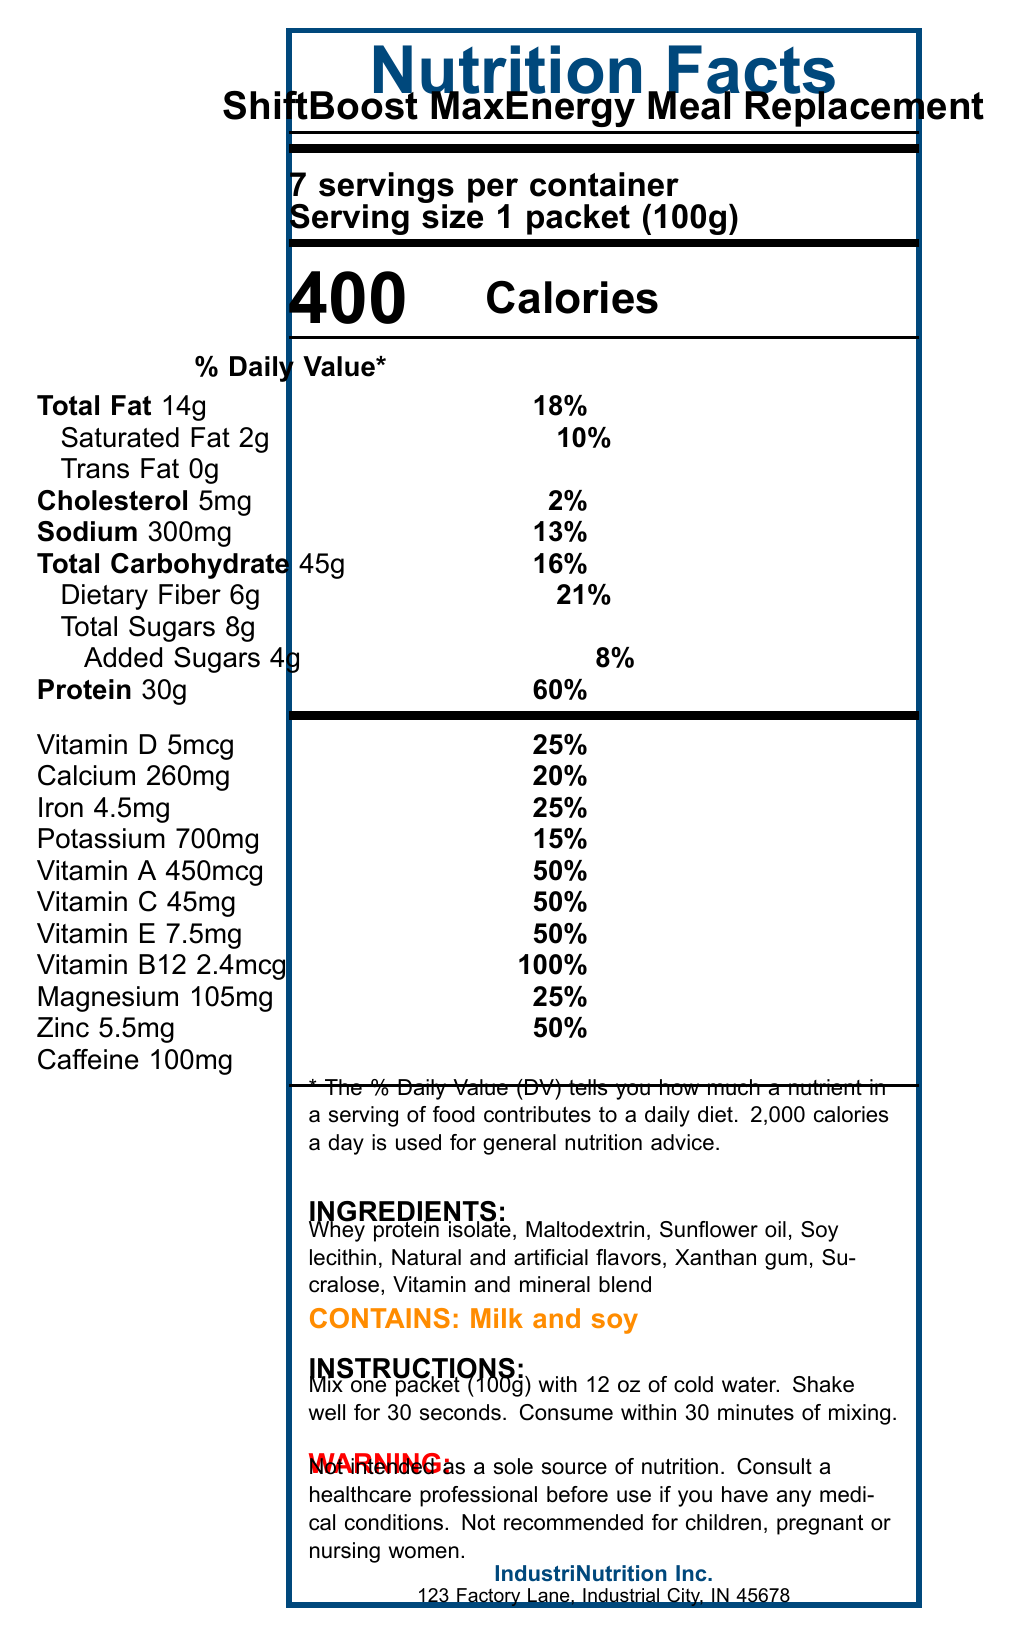what is the serving size of ShiftBoost MaxEnergy Meal Replacement? The document specifies the serving size as "1 packet (100g)".
Answer: 1 packet (100g) how many servings are there per container? The document states that there are "7 servings per container".
Answer: 7 how many grams of total fat are in one serving? The "Total Fat" section specifies the amount as "14g".
Answer: 14g what is the percentage of daily value for dietary fiber per serving? The document lists the daily value for dietary fiber as "21%".
Answer: 21% what amount of vitamin C is included per serving? The document shows the vitamin C content as "45mg".
Answer: 45mg what is the total amount of added sugars per serving? The "Added Sugars" section specifies the amount as "4g".
Answer: 4g how much protein does one serving contain? A. 14g B. 30g C. 45g D. 60g The document lists the protein content per serving as "30g".
Answer: B. 30g what is the total carbohydrate content per serving? A. 13g B. 45g C. 21g D. 30g The "Total Carbohydrate" section specifies the amount as "45g".
Answer: B. 45g does the ShiftBoost MaxEnergy Meal Replacement contain caffeine? The document includes "Caffeine 100mg" under the nutrient information.
Answer: Yes is this product recommended for children, pregnant, or nursing women? The safety warnings clearly state that it is "Not recommended for children, pregnant or nursing women".
Answer: No what are the main ingredients of ShiftBoost MaxEnergy Meal Replacement? The document lists these ingredients under the "INGREDIENTS" section.
Answer: Whey protein isolate, Maltodextrin, Sunflower oil, Soy lecithin, Natural and artificial flavors, Xanthan gum, Sucralose, Vitamin and mineral blend summarize the main information provided in the Nutrition Facts Label. The document provides comprehensive nutritional data, serving details, ingredient list, allergens, preparation instructions, safety warnings, and contact information for ShiftBoost MaxEnergy Meal Replacement.
Answer: The ShiftBoost MaxEnergy Meal Replacement provides detailed nutritional information per serving, which includes 400 calories, 14g of total fat, 30g of protein, and various vitamins and minerals. It highlights percentage daily values, ingredients, allergens, preparation, and safety instructions, as well as manufacturer details. what certifications does IndustriNutrition Inc. have? The certifications are not shown in the document. The answer cannot be determined based on the visual information provided.
Answer: Cannot be determined what is the sodium content per serving? The document specifies the sodium content as "300mg".
Answer: 300mg how much calcium does one serving contain? The document lists the calcium content as "260mg".
Answer: 260mg what is the serving size of this meal replacement? The document specifies the serving size as "1 packet (100g)".
Answer: 1 packet (100g) how many milligrams of magnesium are in one serving? The magnesium content per serving is listed as "105mg".
Answer: 105mg 